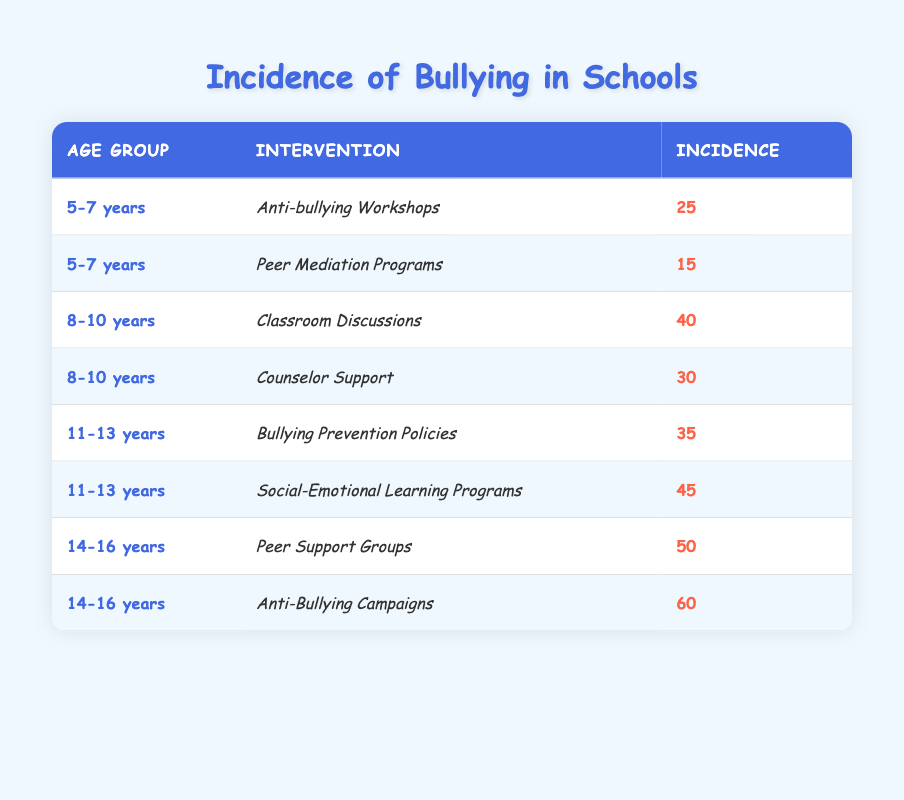What is the incidence of bullying for the age group 5-7 years under the intervention "Peer Mediation Programs"? In the table, I find the "5-7 years" age group and look for the associated interventions. The second intervention listed for this age group is "Peer Mediation Programs" with an incidence of 15.
Answer: 15 Which intervention had the highest incidence of bullying in the age group 11-13 years? In the table, I look for the age group "11-13 years" and compare the incidences for both interventions: "Bullying Prevention Policies" has an incidence of 35, while "Social-Emotional Learning Programs" has 45. Therefore, "Social-Emotional Learning Programs" has the highest incidence.
Answer: Social-Emotional Learning Programs What is the total incidence of bullying for the age group 14-16 years? I identify the age group "14-16 years" in the table, which includes two interventions: "Peer Support Groups" with 50 and "Anti-Bullying Campaigns" with 60. Adding these incidences together gives me 50 + 60 = 110.
Answer: 110 Is the incidence of bullying lower for "Anti-bullying Workshops" compared to "Classroom Discussions"? I check the incidence for "Anti-bullying Workshops," which is 25, and "Classroom Discussions," which is 40. Since 25 is less than 40, I can confirm that the incidence is lower for "Anti-bullying Workshops."
Answer: Yes What is the average incidence of bullying across all interventions listed for the age groups? To calculate the average, I first sum all the incidences: 25 + 15 + 40 + 30 + 35 + 45 + 50 + 60 = 250. There are 8 interventions total, so I divide the total incidence by 8: 250 / 8 = 31.25.
Answer: 31.25 How does the incidence of bullying for "Counselor Support" compare to "Peer Support Groups"? Looking at the table, "Counselor Support" has an incidence of 30, while "Peer Support Groups" has an incidence of 50. Since 30 is less than 50, I conclude that the incidence for "Counselor Support" is lower than for "Peer Support Groups."
Answer: Yes Which age group has the lowest incidence of bullying across all interventions? I review the table for each age group. The lowest incidences are: 5-7 years has 15, 8-10 years has 30, 11-13 years has 35, and 14-16 years has 50. The lowest value is 15 for the age group 5-7 years with "Peer Mediation Programs."
Answer: 5-7 years Are there more effective interventions for older children (14-16 years) compared to younger children (5-7 years) in terms of incidence? To determine effectiveness based on incidence, I analyze the highest values from both age groups. The highest intervention for 5-7 years is 25 ("Anti-bullying Workshops"), while for 14-16 years it is 60 ("Anti-Bullying Campaigns"). Since 60 is greater than 25, this indicates that older children experience a higher incidence.
Answer: Yes 